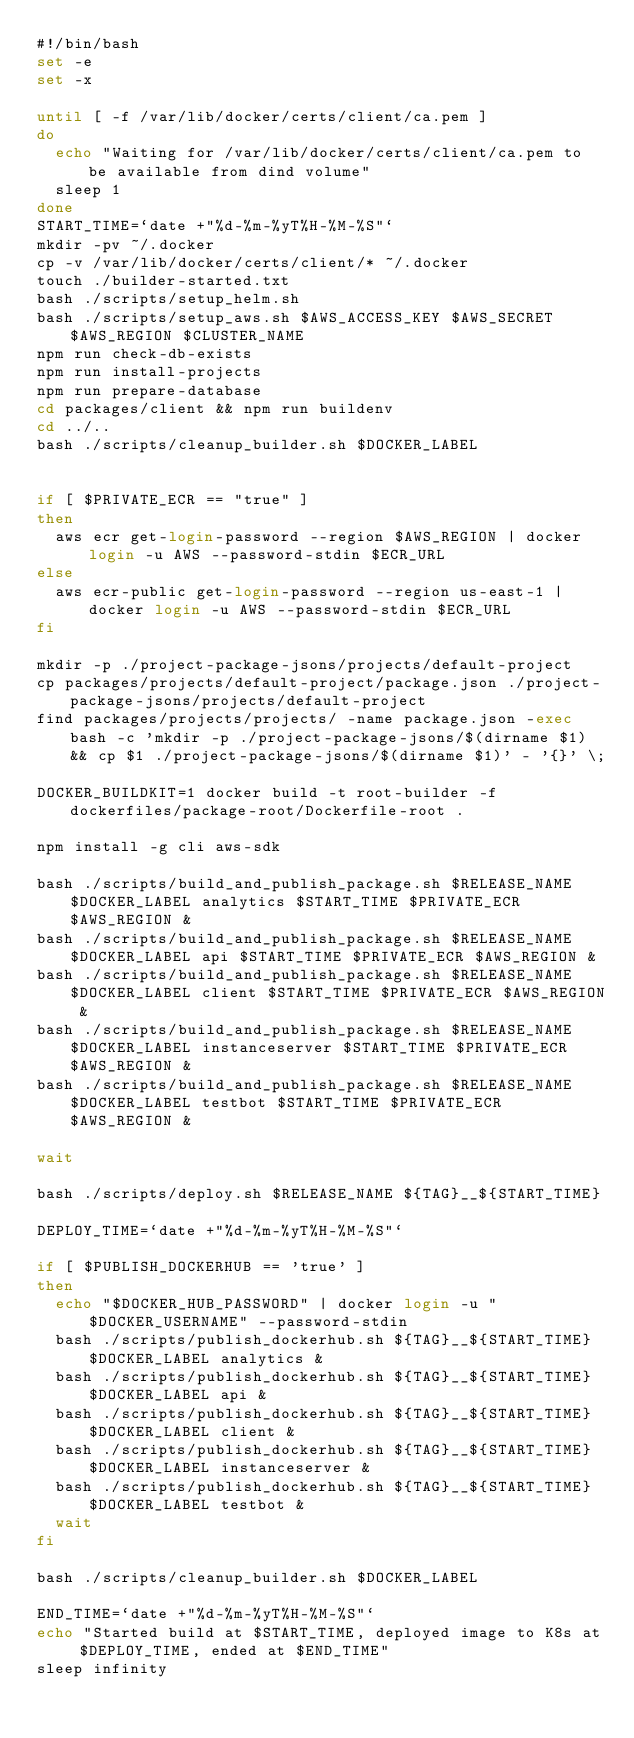<code> <loc_0><loc_0><loc_500><loc_500><_Bash_>#!/bin/bash
set -e
set -x

until [ -f /var/lib/docker/certs/client/ca.pem ]
do
  echo "Waiting for /var/lib/docker/certs/client/ca.pem to be available from dind volume"
  sleep 1
done
START_TIME=`date +"%d-%m-%yT%H-%M-%S"`
mkdir -pv ~/.docker
cp -v /var/lib/docker/certs/client/* ~/.docker
touch ./builder-started.txt
bash ./scripts/setup_helm.sh
bash ./scripts/setup_aws.sh $AWS_ACCESS_KEY $AWS_SECRET $AWS_REGION $CLUSTER_NAME
npm run check-db-exists
npm run install-projects
npm run prepare-database
cd packages/client && npm run buildenv
cd ../..
bash ./scripts/cleanup_builder.sh $DOCKER_LABEL


if [ $PRIVATE_ECR == "true" ]
then
  aws ecr get-login-password --region $AWS_REGION | docker login -u AWS --password-stdin $ECR_URL
else
  aws ecr-public get-login-password --region us-east-1 | docker login -u AWS --password-stdin $ECR_URL
fi

mkdir -p ./project-package-jsons/projects/default-project
cp packages/projects/default-project/package.json ./project-package-jsons/projects/default-project
find packages/projects/projects/ -name package.json -exec bash -c 'mkdir -p ./project-package-jsons/$(dirname $1) && cp $1 ./project-package-jsons/$(dirname $1)' - '{}' \;

DOCKER_BUILDKIT=1 docker build -t root-builder -f dockerfiles/package-root/Dockerfile-root .

npm install -g cli aws-sdk

bash ./scripts/build_and_publish_package.sh $RELEASE_NAME $DOCKER_LABEL analytics $START_TIME $PRIVATE_ECR $AWS_REGION &
bash ./scripts/build_and_publish_package.sh $RELEASE_NAME $DOCKER_LABEL api $START_TIME $PRIVATE_ECR $AWS_REGION &
bash ./scripts/build_and_publish_package.sh $RELEASE_NAME $DOCKER_LABEL client $START_TIME $PRIVATE_ECR $AWS_REGION &
bash ./scripts/build_and_publish_package.sh $RELEASE_NAME $DOCKER_LABEL instanceserver $START_TIME $PRIVATE_ECR $AWS_REGION &
bash ./scripts/build_and_publish_package.sh $RELEASE_NAME $DOCKER_LABEL testbot $START_TIME $PRIVATE_ECR $AWS_REGION &

wait

bash ./scripts/deploy.sh $RELEASE_NAME ${TAG}__${START_TIME}

DEPLOY_TIME=`date +"%d-%m-%yT%H-%M-%S"`

if [ $PUBLISH_DOCKERHUB == 'true' ]
then
  echo "$DOCKER_HUB_PASSWORD" | docker login -u "$DOCKER_USERNAME" --password-stdin
  bash ./scripts/publish_dockerhub.sh ${TAG}__${START_TIME} $DOCKER_LABEL analytics &
  bash ./scripts/publish_dockerhub.sh ${TAG}__${START_TIME} $DOCKER_LABEL api &
  bash ./scripts/publish_dockerhub.sh ${TAG}__${START_TIME} $DOCKER_LABEL client &
  bash ./scripts/publish_dockerhub.sh ${TAG}__${START_TIME} $DOCKER_LABEL instanceserver &
  bash ./scripts/publish_dockerhub.sh ${TAG}__${START_TIME} $DOCKER_LABEL testbot &
  wait
fi

bash ./scripts/cleanup_builder.sh $DOCKER_LABEL

END_TIME=`date +"%d-%m-%yT%H-%M-%S"`
echo "Started build at $START_TIME, deployed image to K8s at $DEPLOY_TIME, ended at $END_TIME"
sleep infinity
</code> 